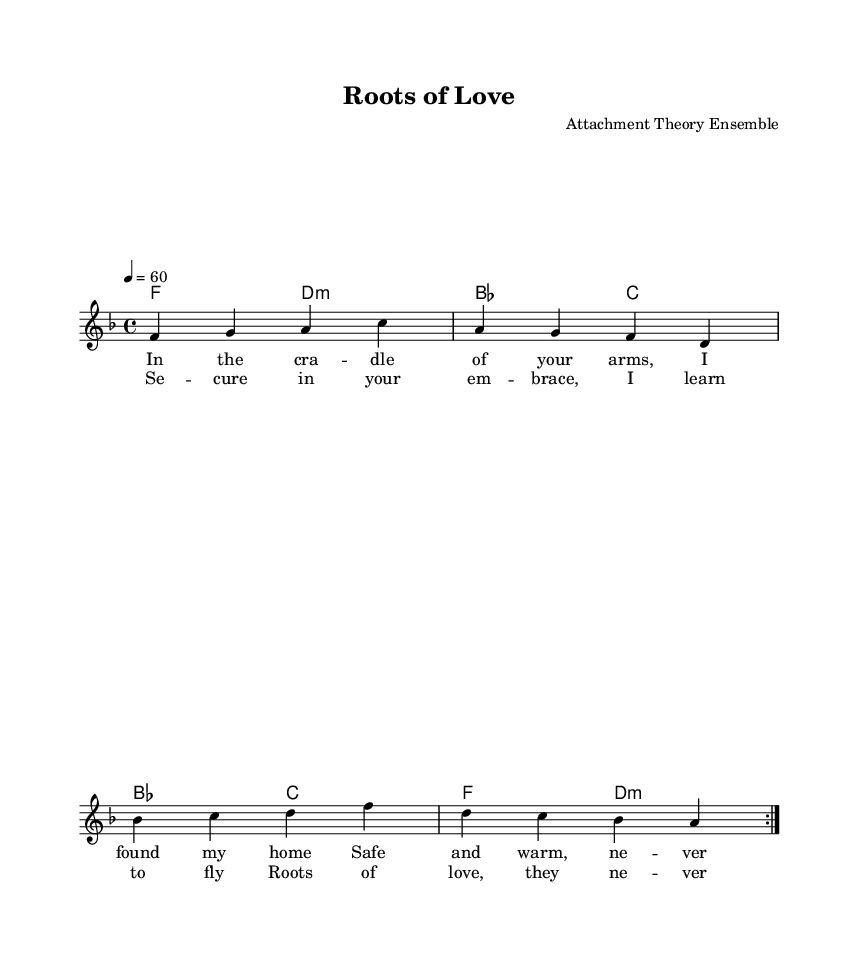What is the key signature of this music? The key signature appears next to the clef at the beginning of the staff and has one flat, indicating F major.
Answer: F major What is the time signature of this music? The time signature is seen as a fraction at the beginning of the staff, indicating that there are four beats in each measure, with a quarter note receiving one beat.
Answer: 4/4 What is the tempo of the piece? The tempo marking indicates that the quarter note is to be played at sixty beats per minute, which is a slow pace.
Answer: 60 How many measures does the melody contain? By counting the groups of notes, the melody has four measures, each containing a repeat indicating a total of eight.
Answer: Eight What is the primary lyrical theme of the song? The lyrics emphasize feelings of safety, love, and secure attachment, which is highlighted through phrases about home and learning to fly in a secure embrace.
Answer: Secure attachment Which chord appears most frequently in the harmonies? By analyzing the chord progression, the F major chord appears as the starting chord in multiple repetitions throughout the piece.
Answer: F What is the overall structure of the song? The song has a clear verse and chorus form, repeating both sections of lyrics, indicating a common structure in ballads.
Answer: Verse and chorus 